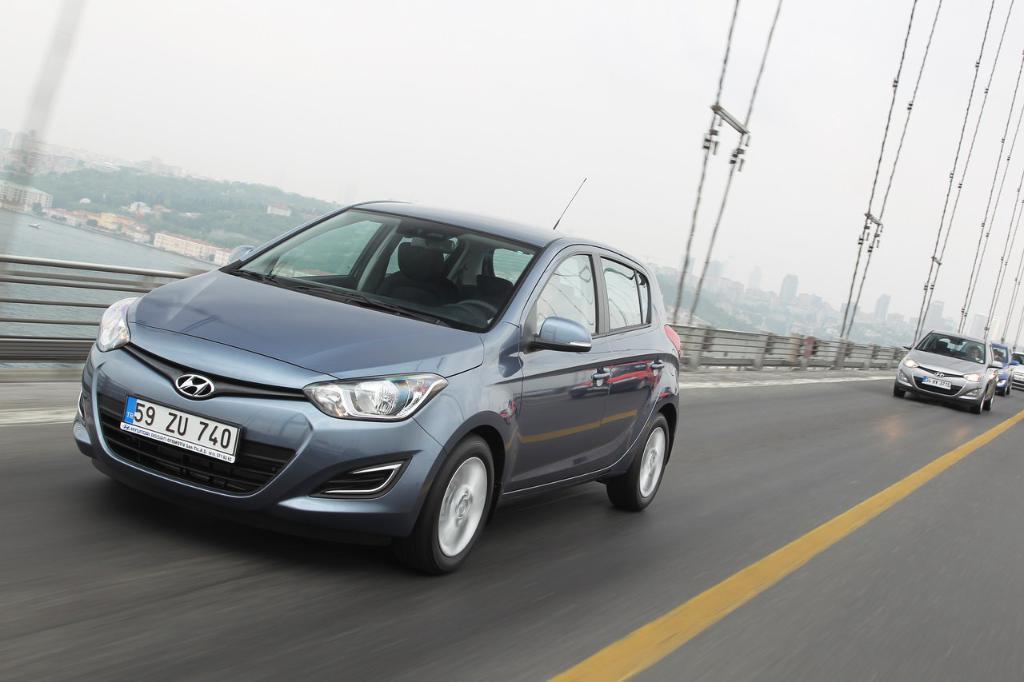In one or two sentences, can you explain what this image depicts? In this image in the center there are some vehicles, and at the bottom there is a walkway. And in the center of the image there is a railing and some wires, and in the background there are trees, buildings, houses, mountains, and river. At the top there is sky. 